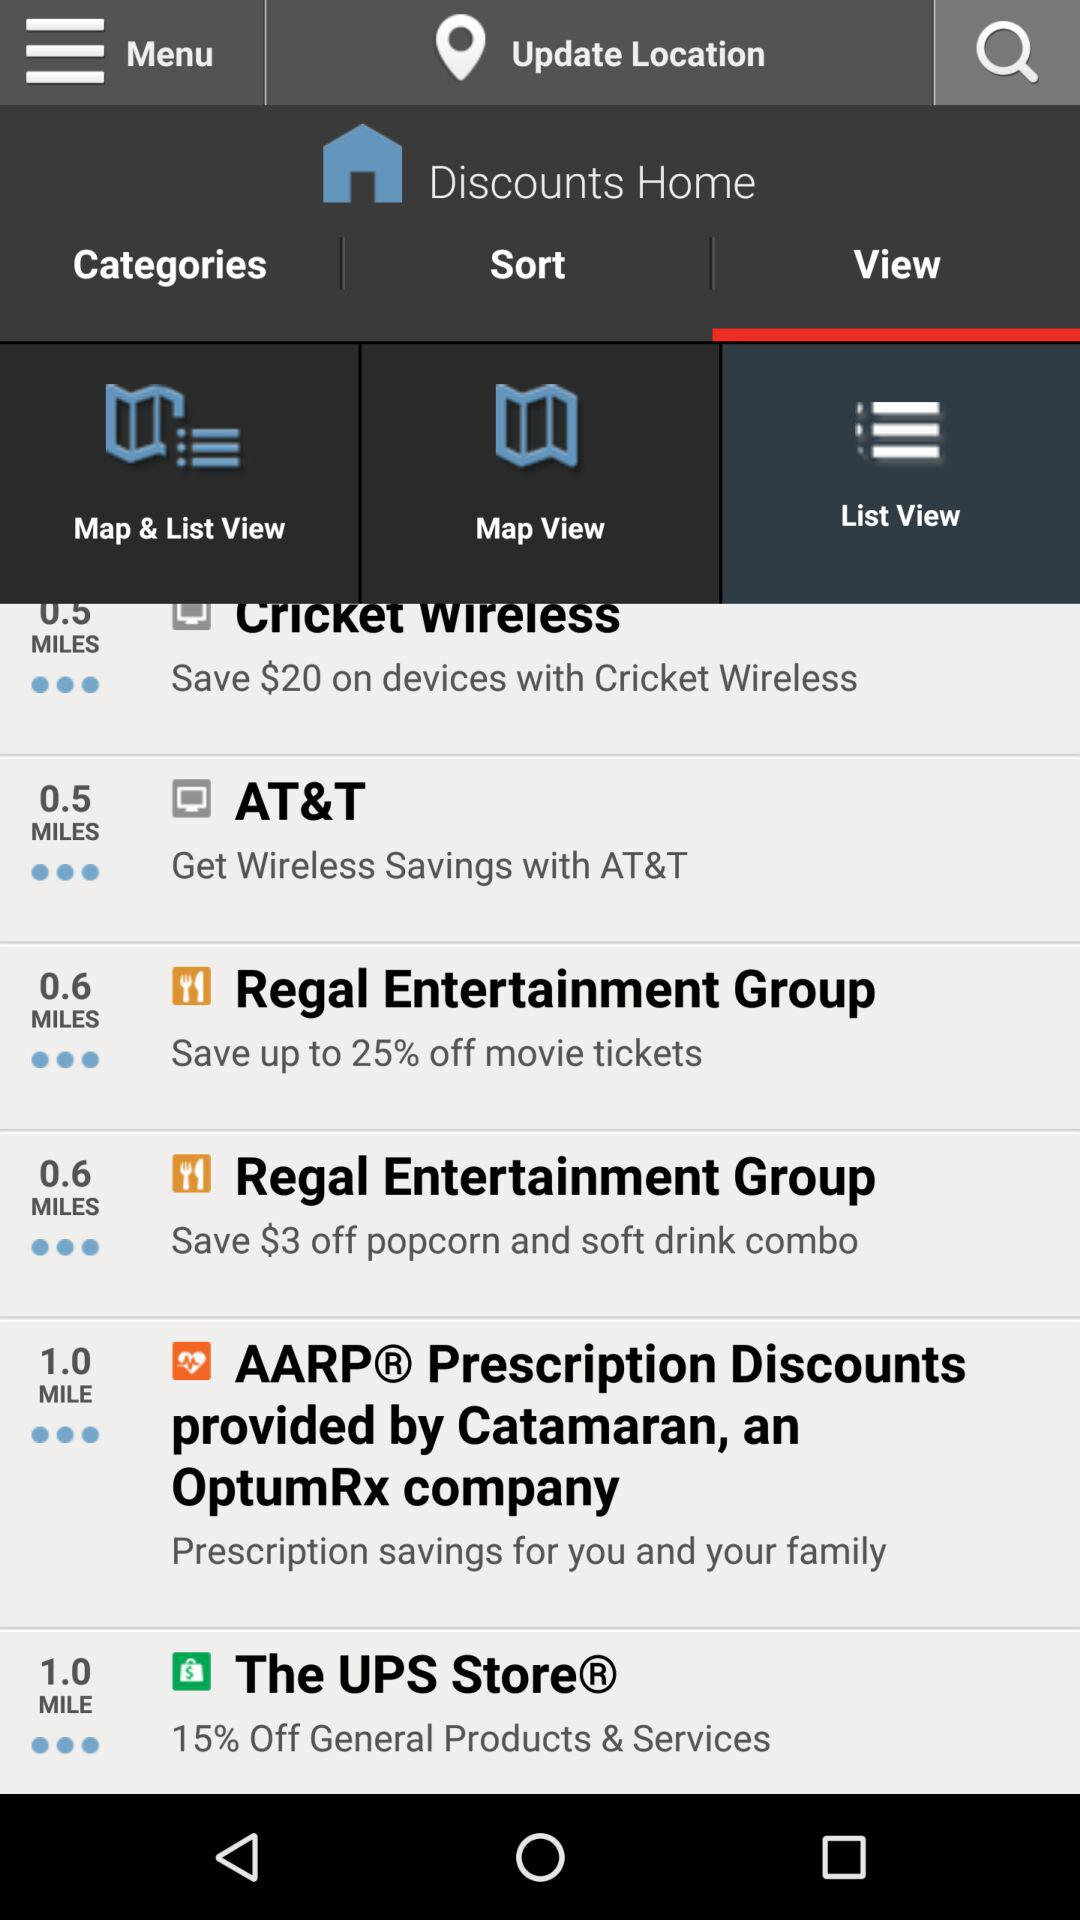On which items can we save $3? You can save $3 on "popcorn" and "soft drink" items. 